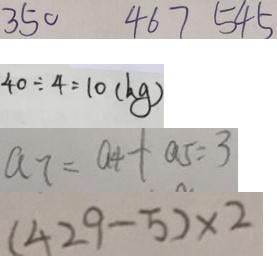<formula> <loc_0><loc_0><loc_500><loc_500>3 5 0 4 6 7 5 4 5 
 4 0 \div 4 = 1 0 ( k g ) 
 a _ { 7 } = a _ { 4 } + a _ { 5 } = 3 
 ( 4 2 9 - 5 ) \times 2</formula> 